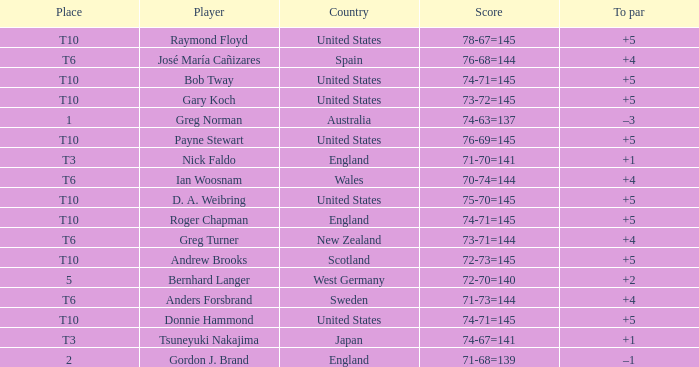I'm looking to parse the entire table for insights. Could you assist me with that? {'header': ['Place', 'Player', 'Country', 'Score', 'To par'], 'rows': [['T10', 'Raymond Floyd', 'United States', '78-67=145', '+5'], ['T6', 'José María Cañizares', 'Spain', '76-68=144', '+4'], ['T10', 'Bob Tway', 'United States', '74-71=145', '+5'], ['T10', 'Gary Koch', 'United States', '73-72=145', '+5'], ['1', 'Greg Norman', 'Australia', '74-63=137', '–3'], ['T10', 'Payne Stewart', 'United States', '76-69=145', '+5'], ['T3', 'Nick Faldo', 'England', '71-70=141', '+1'], ['T6', 'Ian Woosnam', 'Wales', '70-74=144', '+4'], ['T10', 'D. A. Weibring', 'United States', '75-70=145', '+5'], ['T10', 'Roger Chapman', 'England', '74-71=145', '+5'], ['T6', 'Greg Turner', 'New Zealand', '73-71=144', '+4'], ['T10', 'Andrew Brooks', 'Scotland', '72-73=145', '+5'], ['5', 'Bernhard Langer', 'West Germany', '72-70=140', '+2'], ['T6', 'Anders Forsbrand', 'Sweden', '71-73=144', '+4'], ['T10', 'Donnie Hammond', 'United States', '74-71=145', '+5'], ['T3', 'Tsuneyuki Nakajima', 'Japan', '74-67=141', '+1'], ['2', 'Gordon J. Brand', 'England', '71-68=139', '–1']]} What is Greg Norman's place? 1.0. 